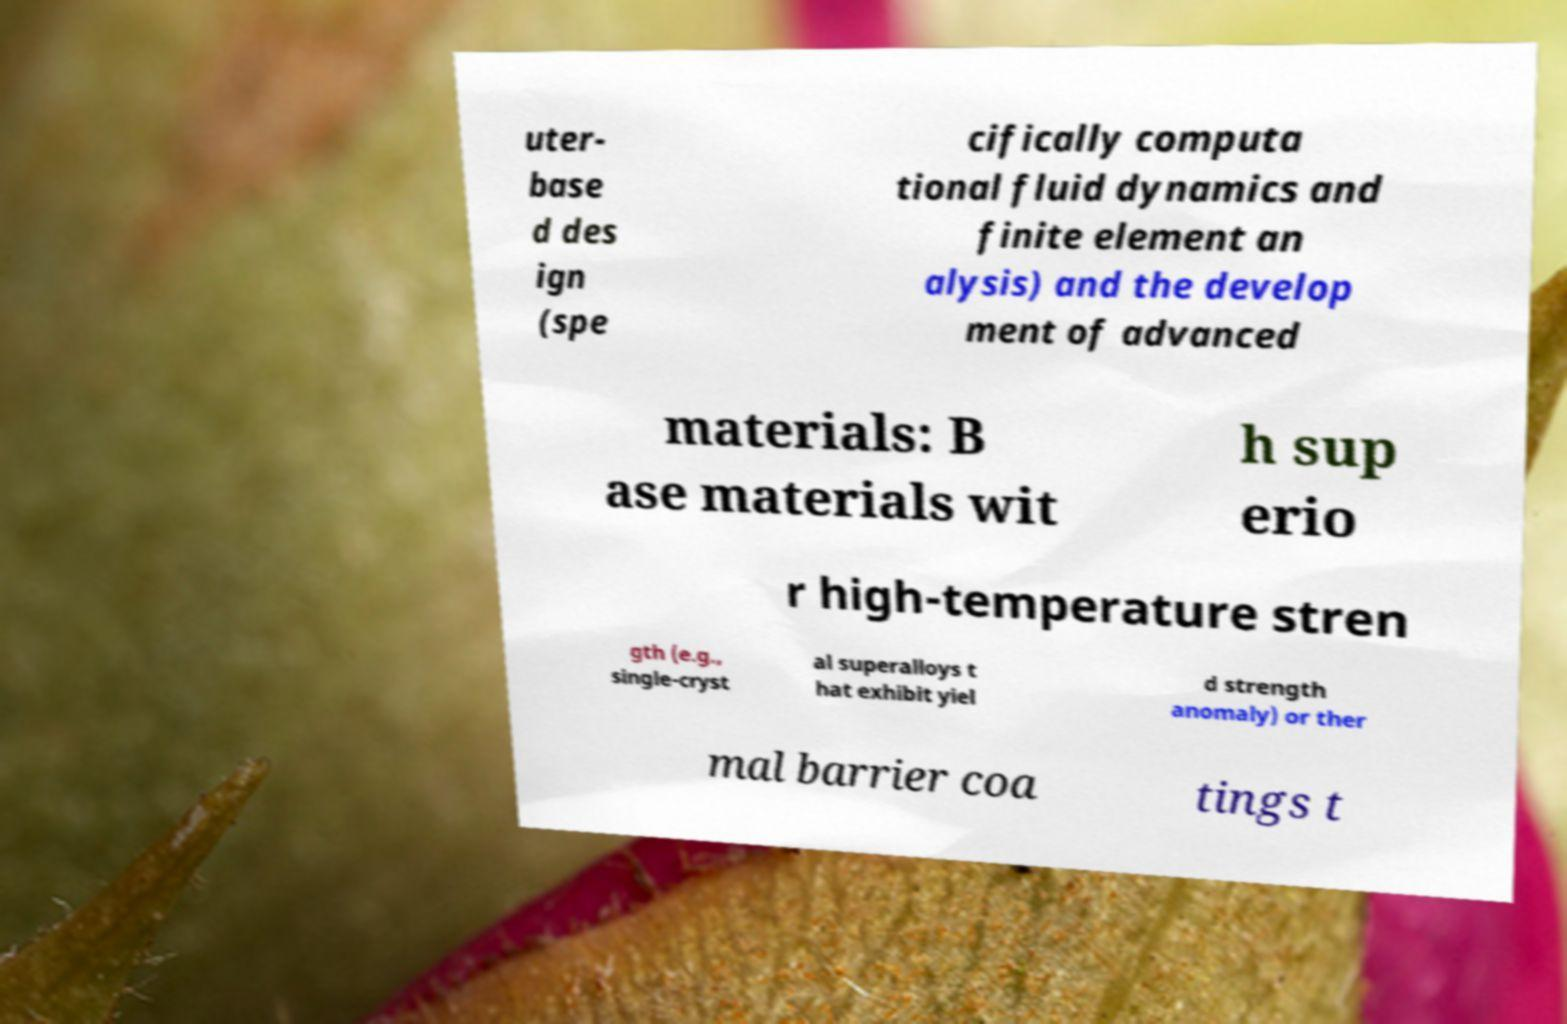I need the written content from this picture converted into text. Can you do that? uter- base d des ign (spe cifically computa tional fluid dynamics and finite element an alysis) and the develop ment of advanced materials: B ase materials wit h sup erio r high-temperature stren gth (e.g., single-cryst al superalloys t hat exhibit yiel d strength anomaly) or ther mal barrier coa tings t 